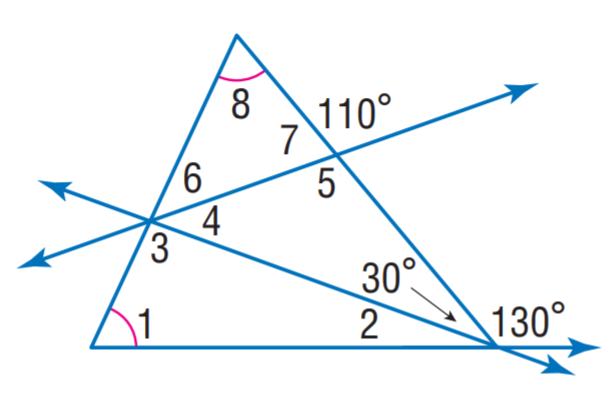Answer the mathemtical geometry problem and directly provide the correct option letter.
Question: Find m \angle 7.
Choices: A: 50 B: 65 C: 70 D: 85 C 